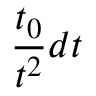<formula> <loc_0><loc_0><loc_500><loc_500>\frac { t _ { 0 } } { t ^ { 2 } } d t</formula> 